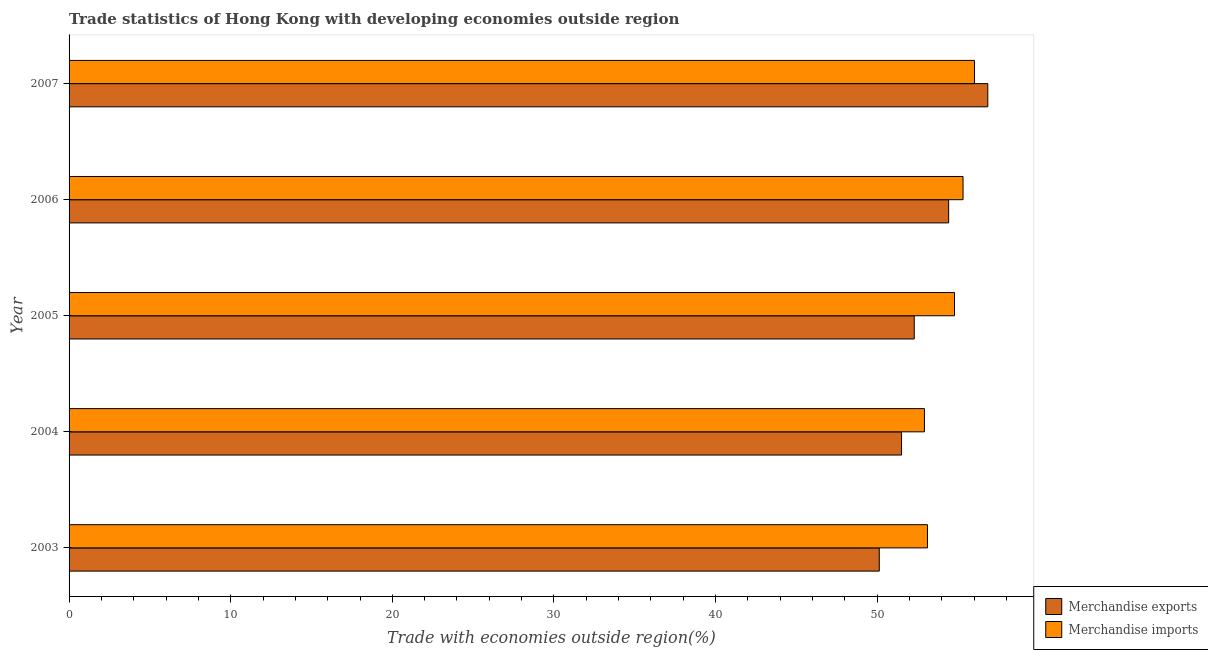How many different coloured bars are there?
Your response must be concise. 2. How many groups of bars are there?
Ensure brevity in your answer.  5. Are the number of bars per tick equal to the number of legend labels?
Ensure brevity in your answer.  Yes. What is the label of the 1st group of bars from the top?
Your response must be concise. 2007. In how many cases, is the number of bars for a given year not equal to the number of legend labels?
Keep it short and to the point. 0. What is the merchandise exports in 2005?
Keep it short and to the point. 52.29. Across all years, what is the maximum merchandise imports?
Provide a succinct answer. 56.02. Across all years, what is the minimum merchandise exports?
Offer a terse response. 50.13. In which year was the merchandise exports minimum?
Keep it short and to the point. 2003. What is the total merchandise exports in the graph?
Your answer should be very brief. 265.18. What is the difference between the merchandise imports in 2004 and that in 2007?
Offer a terse response. -3.1. What is the difference between the merchandise imports in 2004 and the merchandise exports in 2005?
Offer a terse response. 0.63. What is the average merchandise imports per year?
Your answer should be compact. 54.43. In the year 2003, what is the difference between the merchandise exports and merchandise imports?
Your answer should be very brief. -2.98. In how many years, is the merchandise exports greater than 46 %?
Provide a succinct answer. 5. What is the ratio of the merchandise exports in 2003 to that in 2005?
Keep it short and to the point. 0.96. Is the merchandise imports in 2005 less than that in 2007?
Your response must be concise. Yes. Is the difference between the merchandise exports in 2004 and 2006 greater than the difference between the merchandise imports in 2004 and 2006?
Your answer should be compact. No. What is the difference between the highest and the second highest merchandise exports?
Offer a terse response. 2.42. What is the difference between the highest and the lowest merchandise exports?
Your response must be concise. 6.71. In how many years, is the merchandise imports greater than the average merchandise imports taken over all years?
Provide a short and direct response. 3. How many years are there in the graph?
Keep it short and to the point. 5. What is the difference between two consecutive major ticks on the X-axis?
Provide a succinct answer. 10. Does the graph contain any zero values?
Offer a very short reply. No. Does the graph contain grids?
Offer a very short reply. No. How many legend labels are there?
Give a very brief answer. 2. How are the legend labels stacked?
Provide a short and direct response. Vertical. What is the title of the graph?
Offer a very short reply. Trade statistics of Hong Kong with developing economies outside region. What is the label or title of the X-axis?
Provide a short and direct response. Trade with economies outside region(%). What is the Trade with economies outside region(%) of Merchandise exports in 2003?
Keep it short and to the point. 50.13. What is the Trade with economies outside region(%) of Merchandise imports in 2003?
Offer a terse response. 53.11. What is the Trade with economies outside region(%) of Merchandise exports in 2004?
Ensure brevity in your answer.  51.5. What is the Trade with economies outside region(%) in Merchandise imports in 2004?
Give a very brief answer. 52.92. What is the Trade with economies outside region(%) of Merchandise exports in 2005?
Ensure brevity in your answer.  52.29. What is the Trade with economies outside region(%) of Merchandise imports in 2005?
Ensure brevity in your answer.  54.78. What is the Trade with economies outside region(%) in Merchandise exports in 2006?
Make the answer very short. 54.42. What is the Trade with economies outside region(%) of Merchandise imports in 2006?
Your response must be concise. 55.31. What is the Trade with economies outside region(%) of Merchandise exports in 2007?
Provide a succinct answer. 56.84. What is the Trade with economies outside region(%) in Merchandise imports in 2007?
Ensure brevity in your answer.  56.02. Across all years, what is the maximum Trade with economies outside region(%) of Merchandise exports?
Your response must be concise. 56.84. Across all years, what is the maximum Trade with economies outside region(%) of Merchandise imports?
Offer a very short reply. 56.02. Across all years, what is the minimum Trade with economies outside region(%) of Merchandise exports?
Offer a very short reply. 50.13. Across all years, what is the minimum Trade with economies outside region(%) of Merchandise imports?
Ensure brevity in your answer.  52.92. What is the total Trade with economies outside region(%) of Merchandise exports in the graph?
Offer a very short reply. 265.18. What is the total Trade with economies outside region(%) in Merchandise imports in the graph?
Keep it short and to the point. 272.14. What is the difference between the Trade with economies outside region(%) in Merchandise exports in 2003 and that in 2004?
Provide a succinct answer. -1.38. What is the difference between the Trade with economies outside region(%) of Merchandise imports in 2003 and that in 2004?
Offer a very short reply. 0.19. What is the difference between the Trade with economies outside region(%) of Merchandise exports in 2003 and that in 2005?
Give a very brief answer. -2.16. What is the difference between the Trade with economies outside region(%) of Merchandise imports in 2003 and that in 2005?
Keep it short and to the point. -1.67. What is the difference between the Trade with economies outside region(%) of Merchandise exports in 2003 and that in 2006?
Your response must be concise. -4.29. What is the difference between the Trade with economies outside region(%) in Merchandise imports in 2003 and that in 2006?
Ensure brevity in your answer.  -2.2. What is the difference between the Trade with economies outside region(%) in Merchandise exports in 2003 and that in 2007?
Provide a succinct answer. -6.71. What is the difference between the Trade with economies outside region(%) in Merchandise imports in 2003 and that in 2007?
Your answer should be compact. -2.91. What is the difference between the Trade with economies outside region(%) of Merchandise exports in 2004 and that in 2005?
Keep it short and to the point. -0.79. What is the difference between the Trade with economies outside region(%) in Merchandise imports in 2004 and that in 2005?
Your answer should be compact. -1.86. What is the difference between the Trade with economies outside region(%) in Merchandise exports in 2004 and that in 2006?
Your answer should be compact. -2.91. What is the difference between the Trade with economies outside region(%) in Merchandise imports in 2004 and that in 2006?
Offer a terse response. -2.39. What is the difference between the Trade with economies outside region(%) of Merchandise exports in 2004 and that in 2007?
Your answer should be compact. -5.34. What is the difference between the Trade with economies outside region(%) of Merchandise imports in 2004 and that in 2007?
Provide a short and direct response. -3.1. What is the difference between the Trade with economies outside region(%) of Merchandise exports in 2005 and that in 2006?
Offer a very short reply. -2.13. What is the difference between the Trade with economies outside region(%) of Merchandise imports in 2005 and that in 2006?
Provide a succinct answer. -0.53. What is the difference between the Trade with economies outside region(%) in Merchandise exports in 2005 and that in 2007?
Keep it short and to the point. -4.55. What is the difference between the Trade with economies outside region(%) in Merchandise imports in 2005 and that in 2007?
Your answer should be compact. -1.24. What is the difference between the Trade with economies outside region(%) in Merchandise exports in 2006 and that in 2007?
Make the answer very short. -2.42. What is the difference between the Trade with economies outside region(%) of Merchandise imports in 2006 and that in 2007?
Your answer should be compact. -0.71. What is the difference between the Trade with economies outside region(%) of Merchandise exports in 2003 and the Trade with economies outside region(%) of Merchandise imports in 2004?
Provide a short and direct response. -2.79. What is the difference between the Trade with economies outside region(%) in Merchandise exports in 2003 and the Trade with economies outside region(%) in Merchandise imports in 2005?
Offer a terse response. -4.65. What is the difference between the Trade with economies outside region(%) of Merchandise exports in 2003 and the Trade with economies outside region(%) of Merchandise imports in 2006?
Offer a very short reply. -5.18. What is the difference between the Trade with economies outside region(%) of Merchandise exports in 2003 and the Trade with economies outside region(%) of Merchandise imports in 2007?
Offer a terse response. -5.89. What is the difference between the Trade with economies outside region(%) in Merchandise exports in 2004 and the Trade with economies outside region(%) in Merchandise imports in 2005?
Your response must be concise. -3.28. What is the difference between the Trade with economies outside region(%) in Merchandise exports in 2004 and the Trade with economies outside region(%) in Merchandise imports in 2006?
Provide a succinct answer. -3.8. What is the difference between the Trade with economies outside region(%) of Merchandise exports in 2004 and the Trade with economies outside region(%) of Merchandise imports in 2007?
Your response must be concise. -4.51. What is the difference between the Trade with economies outside region(%) in Merchandise exports in 2005 and the Trade with economies outside region(%) in Merchandise imports in 2006?
Offer a very short reply. -3.02. What is the difference between the Trade with economies outside region(%) in Merchandise exports in 2005 and the Trade with economies outside region(%) in Merchandise imports in 2007?
Your answer should be very brief. -3.73. What is the difference between the Trade with economies outside region(%) in Merchandise exports in 2006 and the Trade with economies outside region(%) in Merchandise imports in 2007?
Make the answer very short. -1.6. What is the average Trade with economies outside region(%) of Merchandise exports per year?
Ensure brevity in your answer.  53.04. What is the average Trade with economies outside region(%) in Merchandise imports per year?
Your response must be concise. 54.43. In the year 2003, what is the difference between the Trade with economies outside region(%) in Merchandise exports and Trade with economies outside region(%) in Merchandise imports?
Offer a terse response. -2.98. In the year 2004, what is the difference between the Trade with economies outside region(%) in Merchandise exports and Trade with economies outside region(%) in Merchandise imports?
Provide a succinct answer. -1.42. In the year 2005, what is the difference between the Trade with economies outside region(%) in Merchandise exports and Trade with economies outside region(%) in Merchandise imports?
Make the answer very short. -2.49. In the year 2006, what is the difference between the Trade with economies outside region(%) of Merchandise exports and Trade with economies outside region(%) of Merchandise imports?
Your response must be concise. -0.89. In the year 2007, what is the difference between the Trade with economies outside region(%) of Merchandise exports and Trade with economies outside region(%) of Merchandise imports?
Make the answer very short. 0.82. What is the ratio of the Trade with economies outside region(%) of Merchandise exports in 2003 to that in 2004?
Provide a succinct answer. 0.97. What is the ratio of the Trade with economies outside region(%) of Merchandise exports in 2003 to that in 2005?
Give a very brief answer. 0.96. What is the ratio of the Trade with economies outside region(%) of Merchandise imports in 2003 to that in 2005?
Offer a terse response. 0.97. What is the ratio of the Trade with economies outside region(%) in Merchandise exports in 2003 to that in 2006?
Provide a short and direct response. 0.92. What is the ratio of the Trade with economies outside region(%) in Merchandise imports in 2003 to that in 2006?
Provide a succinct answer. 0.96. What is the ratio of the Trade with economies outside region(%) in Merchandise exports in 2003 to that in 2007?
Keep it short and to the point. 0.88. What is the ratio of the Trade with economies outside region(%) in Merchandise imports in 2003 to that in 2007?
Give a very brief answer. 0.95. What is the ratio of the Trade with economies outside region(%) of Merchandise imports in 2004 to that in 2005?
Make the answer very short. 0.97. What is the ratio of the Trade with economies outside region(%) of Merchandise exports in 2004 to that in 2006?
Your answer should be compact. 0.95. What is the ratio of the Trade with economies outside region(%) of Merchandise imports in 2004 to that in 2006?
Provide a short and direct response. 0.96. What is the ratio of the Trade with economies outside region(%) in Merchandise exports in 2004 to that in 2007?
Offer a terse response. 0.91. What is the ratio of the Trade with economies outside region(%) in Merchandise imports in 2004 to that in 2007?
Provide a succinct answer. 0.94. What is the ratio of the Trade with economies outside region(%) in Merchandise exports in 2005 to that in 2006?
Provide a short and direct response. 0.96. What is the ratio of the Trade with economies outside region(%) of Merchandise imports in 2005 to that in 2006?
Offer a very short reply. 0.99. What is the ratio of the Trade with economies outside region(%) of Merchandise exports in 2005 to that in 2007?
Your response must be concise. 0.92. What is the ratio of the Trade with economies outside region(%) in Merchandise imports in 2005 to that in 2007?
Ensure brevity in your answer.  0.98. What is the ratio of the Trade with economies outside region(%) in Merchandise exports in 2006 to that in 2007?
Your answer should be very brief. 0.96. What is the ratio of the Trade with economies outside region(%) of Merchandise imports in 2006 to that in 2007?
Your answer should be very brief. 0.99. What is the difference between the highest and the second highest Trade with economies outside region(%) of Merchandise exports?
Your answer should be very brief. 2.42. What is the difference between the highest and the second highest Trade with economies outside region(%) in Merchandise imports?
Provide a succinct answer. 0.71. What is the difference between the highest and the lowest Trade with economies outside region(%) of Merchandise exports?
Ensure brevity in your answer.  6.71. What is the difference between the highest and the lowest Trade with economies outside region(%) of Merchandise imports?
Provide a succinct answer. 3.1. 